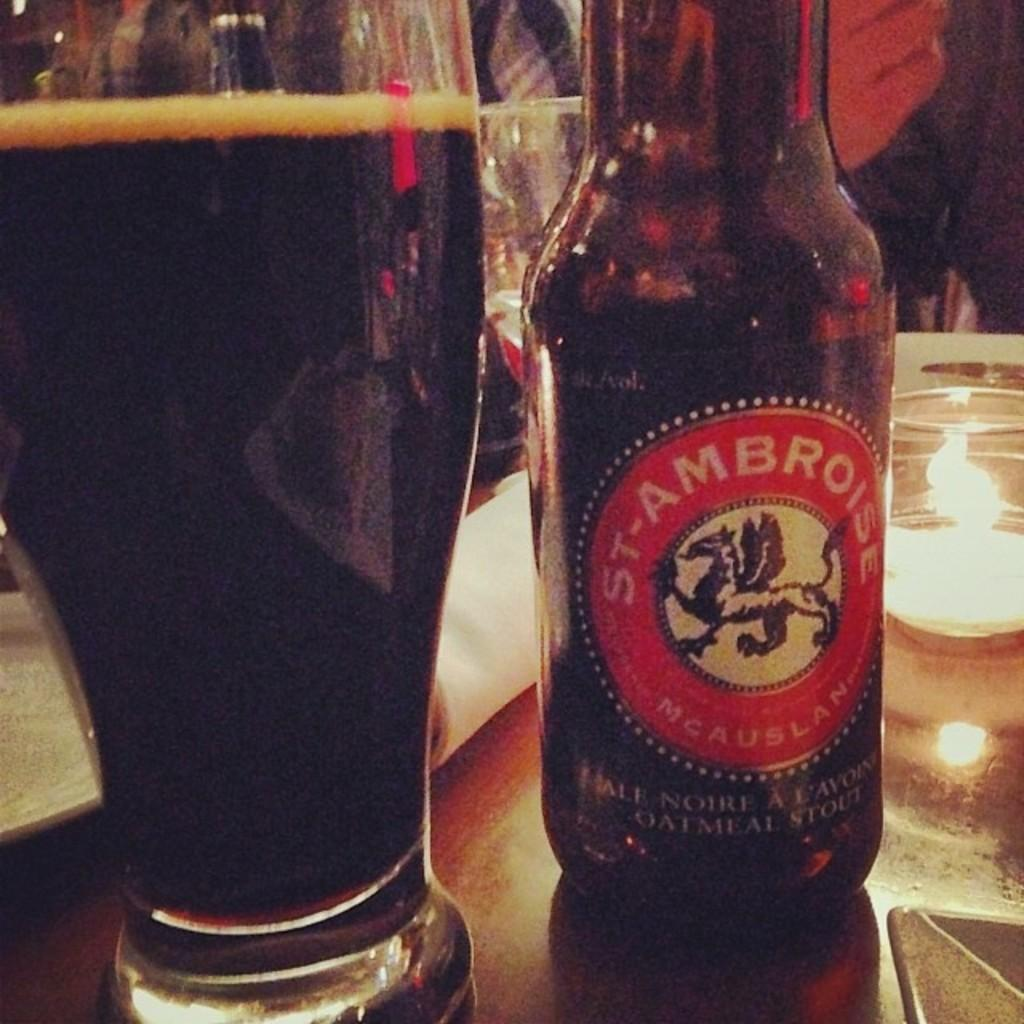What is one of the objects visible on the table in the image? There is a bottle in the image. What else can be seen on the table? There are glasses in the image. What other objects are present on the table? There are other objects on the table, but their specific details are not mentioned in the provided facts. Can you describe any part of a person in the image? Yes, there is a person's hand visible in the background of the image. What type of laughter can be heard coming from space in the image? There is no reference to laughter or space in the image, so it's not possible to determine what, if any, laughter might be heard. 